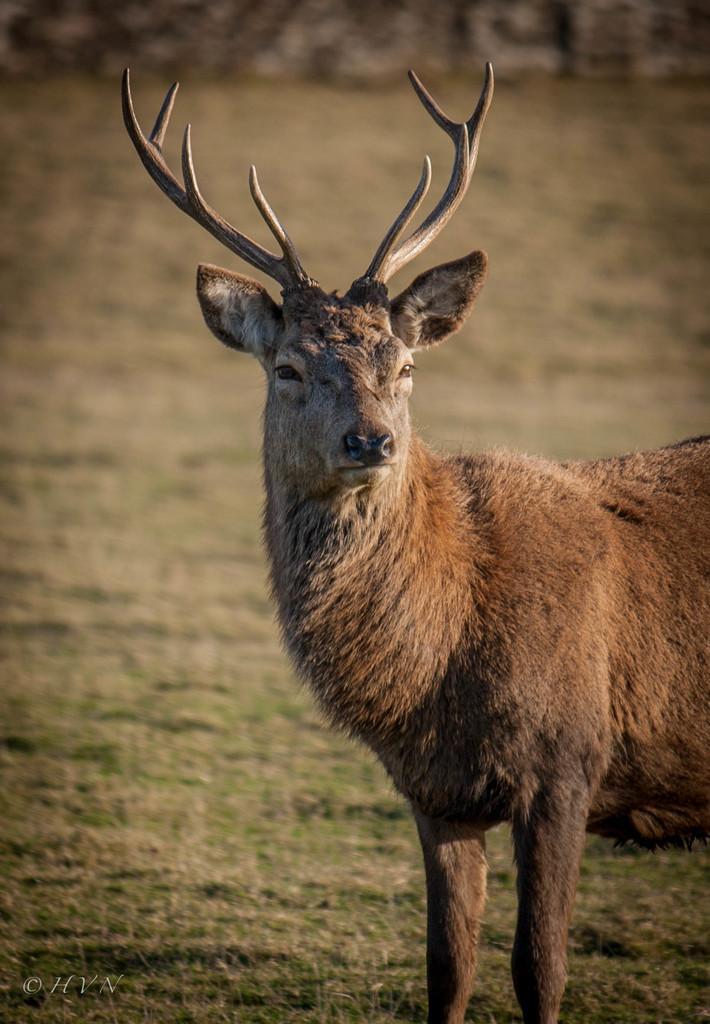Describe this image in one or two sentences. In the foreground of this image, there is a deer on the grass. 